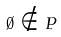Convert formula to latex. <formula><loc_0><loc_0><loc_500><loc_500>\emptyset \notin P</formula> 